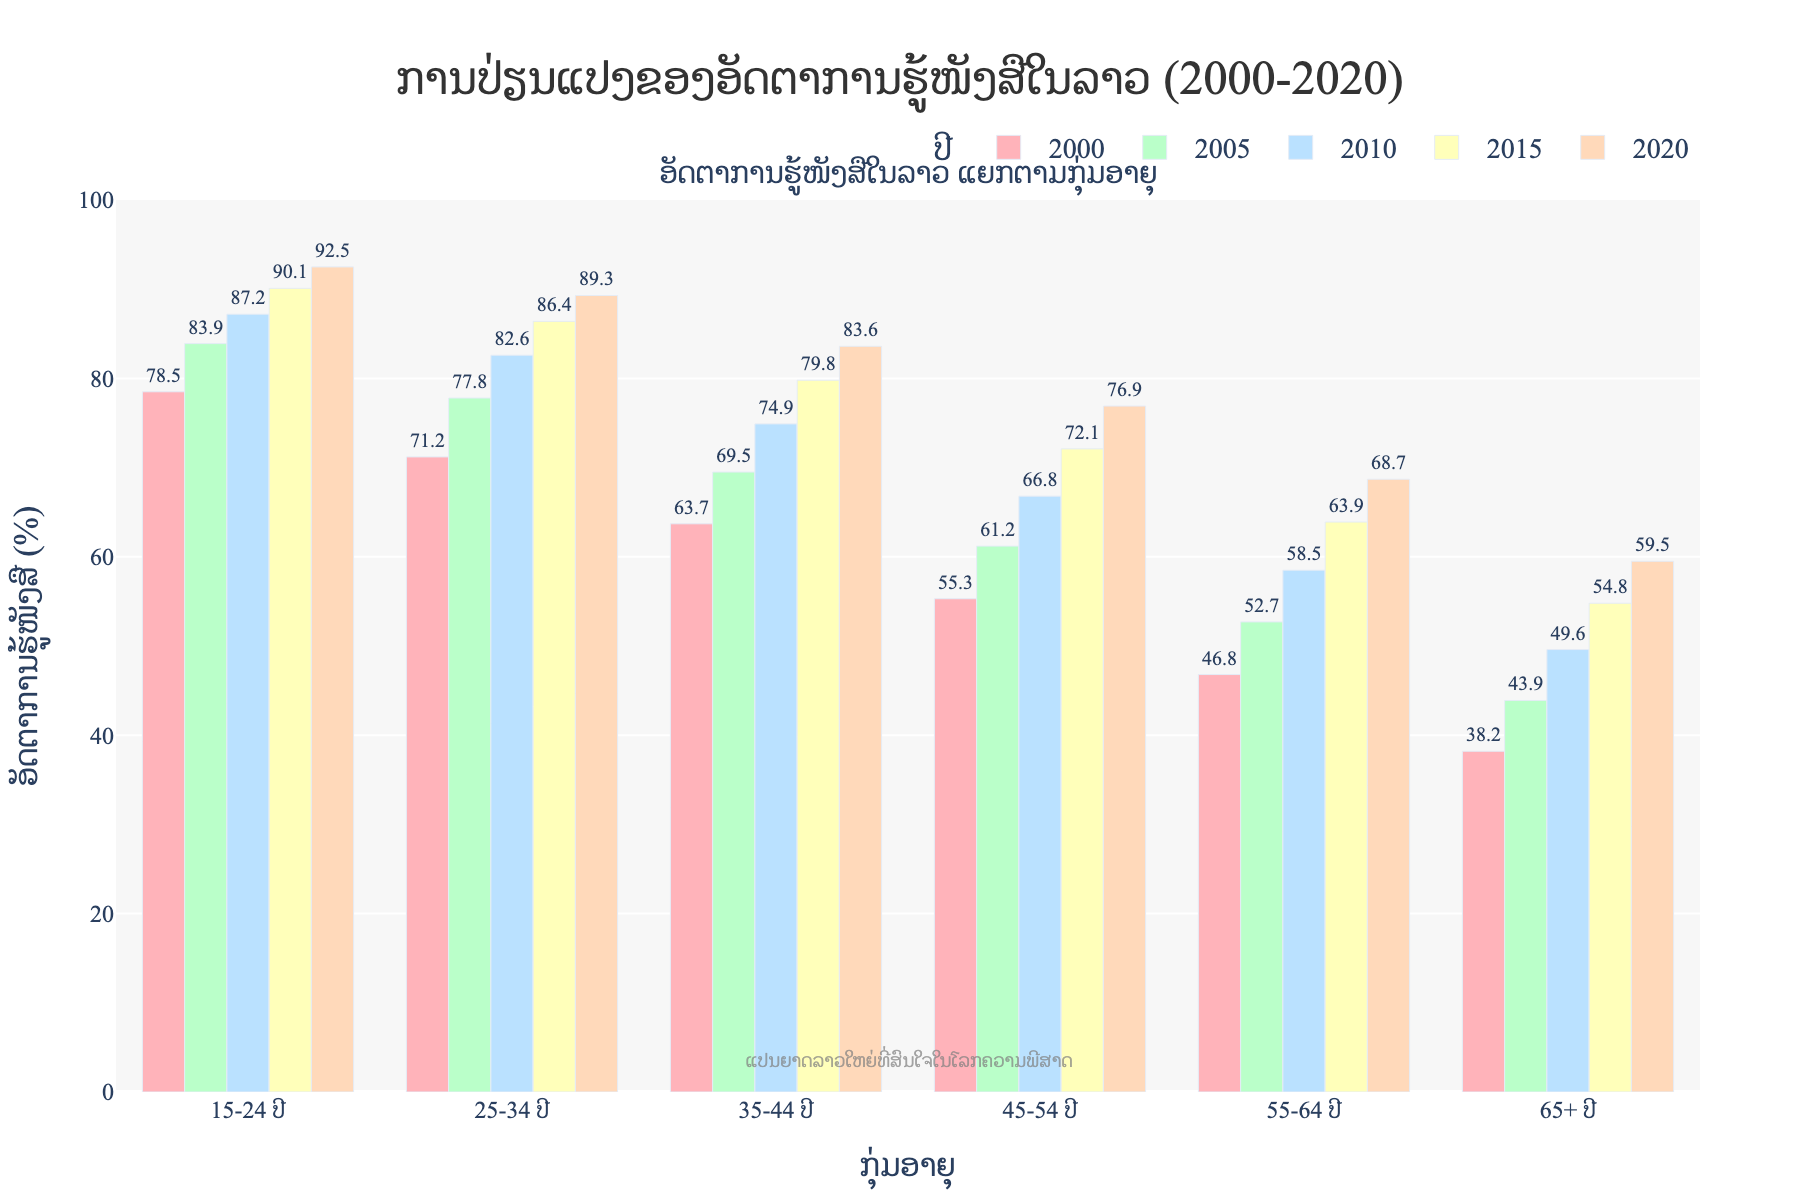What is the overall trend in literacy rates for the age group 15-24 years from 2000 to 2020? The literacy rate for the age group 15-24 years has been increasing steadily from 78.5% in 2000 to 92.5% in 2020. This suggests a positive trend in improving literacy rates within this age group.
Answer: Increasing Which age group had the highest literacy rate in 2020? From the bars representing 2020, the age group 15-24 years had the highest literacy rate of 92.5%.
Answer: 15-24 years Compare the literacy rates between the age groups 55-64 years and 65+ years in 2010. Which group had a higher rate, and by how much? In 2010, the literacy rate for the age group 55-64 years is 58.5%, while for the 65+ age group, it is 49.6%. The 55-64 age group had a higher rate by 58.5% - 49.6% = 8.9%.
Answer: 55-64 years; 8.9% What is the average literacy rate of the age group 25-34 years from 2000 to 2020? Sum the literacy rates for 25-34 years across all five years and divide by the number of years: (71.2 + 77.8 + 82.6 + 86.4 + 89.3) / 5 = 81.46%.
Answer: 81.46% Identify the year with the smallest increase in literacy rates from the previous measurement for the age group 35-44 years. Calculate the difference in literacy rates between consecutive years for 35-44 years: 2005-2000 (69.5-63.7=5.8), 2010-2005 (74.9-69.5=5.4), 2015-2010 (79.8-74.9=4.9), 2020-2015 (83.6-79.8=3.8). The smallest increase occurred from 2015 to 2020 with an increase of 3.8%.
Answer: 2015-2020 How did the literacy rate for the age group 45-54 years change from 2000 to 2015? The literacy rate for the 45-54 age group increased from 55.3% in 2000 to 72.1% in 2015. The change is 72.1% - 55.3% = 16.8%.
Answer: Increased by 16.8% Which decade saw the largest increase in literacy rates for the age group 65+ years? Calculate the increments for each decade: 2000-2010 (49.6-38.2=11.4), 2010-2020 (59.5-49.6=9.9). The largest increase was seen in 2000-2010 with 11.4%.
Answer: 2000-2010 